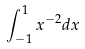Convert formula to latex. <formula><loc_0><loc_0><loc_500><loc_500>\int _ { - 1 } ^ { 1 } x ^ { - 2 } d x</formula> 